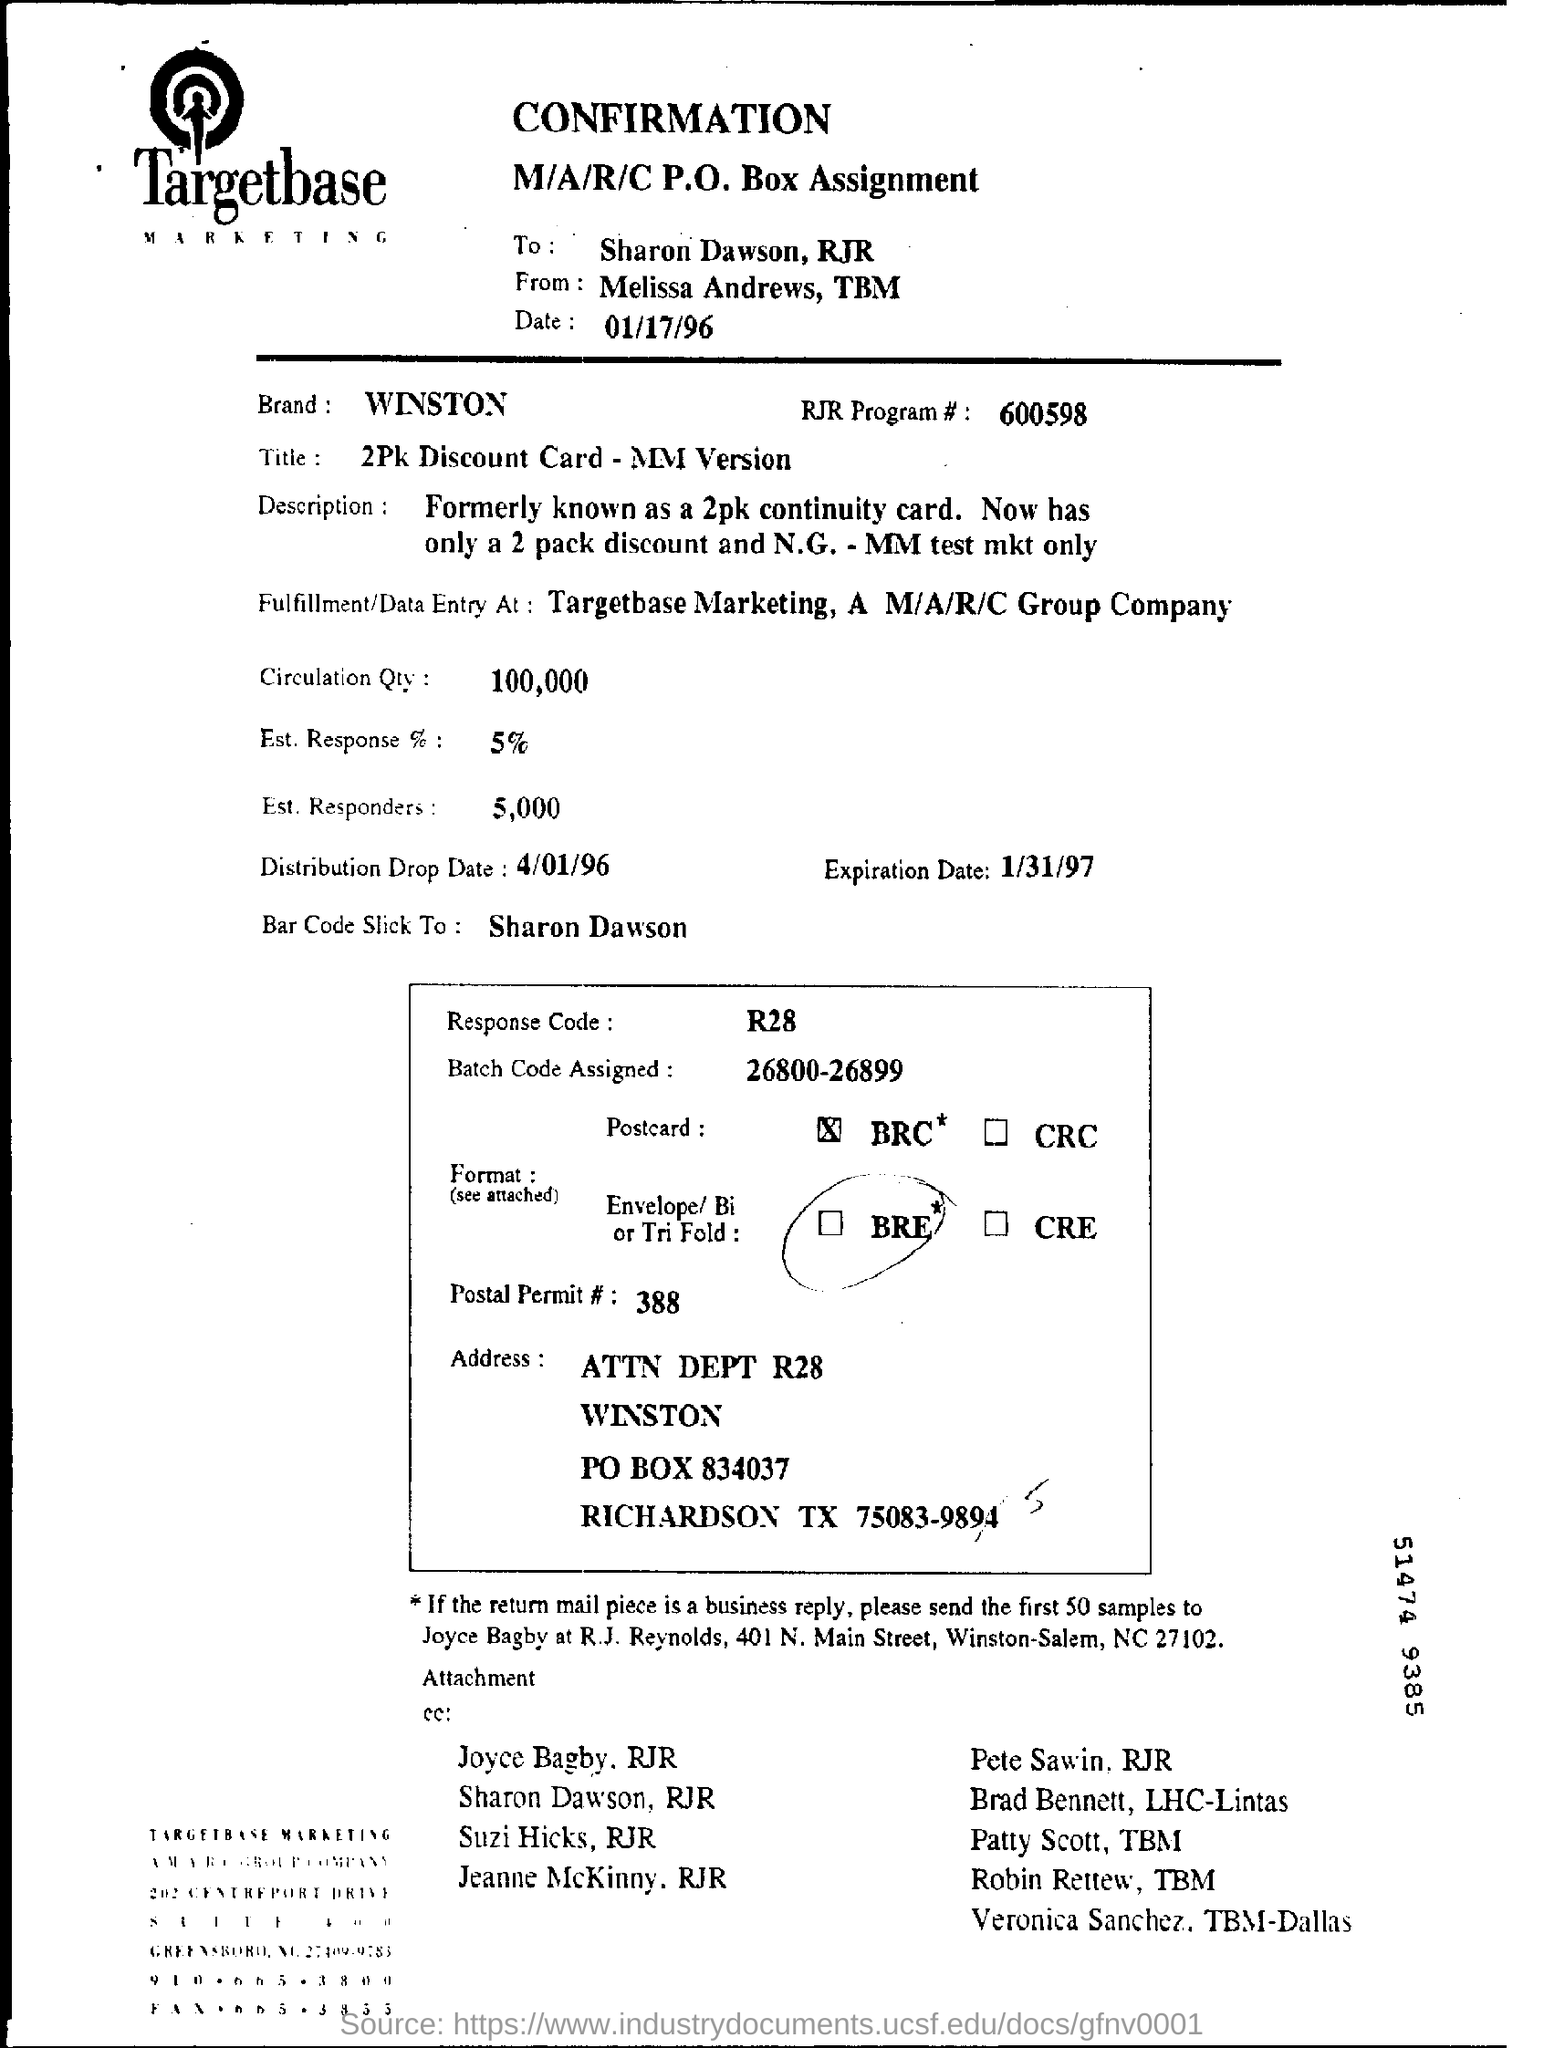What is the RJR Program # ?
Make the answer very short. 600598. To Whom is this document addressed to?
Your answer should be compact. Sharon Dawson, RJR. What is the Distribution Drop Date?
Offer a very short reply. 4/01/96. What is the Postal Permit # ?
Ensure brevity in your answer.  388. What is the Batch Code Assigned?
Your response must be concise. 26800-26899. What is the Response Code?
Ensure brevity in your answer.  R28. 